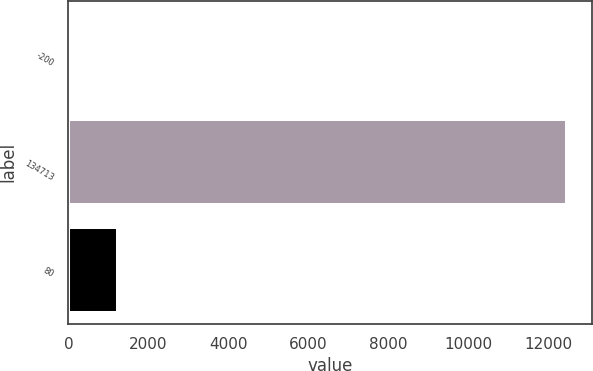Convert chart to OTSL. <chart><loc_0><loc_0><loc_500><loc_500><bar_chart><fcel>-200<fcel>134713<fcel>80<nl><fcel>0.13<fcel>12471.3<fcel>1247.25<nl></chart> 